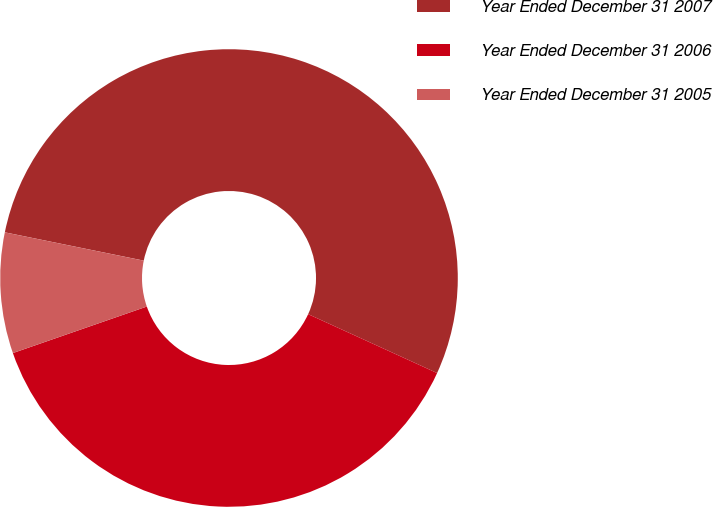Convert chart. <chart><loc_0><loc_0><loc_500><loc_500><pie_chart><fcel>Year Ended December 31 2007<fcel>Year Ended December 31 2006<fcel>Year Ended December 31 2005<nl><fcel>53.62%<fcel>37.86%<fcel>8.52%<nl></chart> 